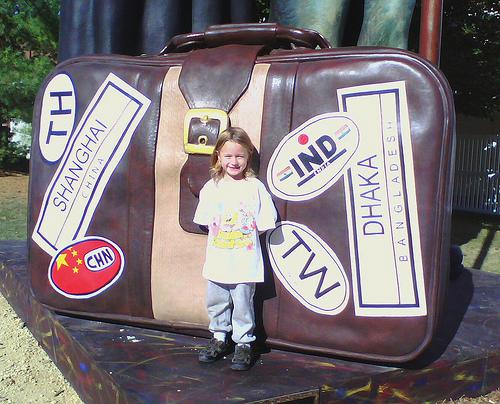Question: how many stickers are on the luggage?
Choices:
A. 6.
B. 5.
C. 2.
D. 3.
Answer with the letter. Answer: A Question: where is there a tree or bush in the photo?
Choices:
A. By the front door.
B. To the left of the luggage.
C. In the background.
D. By the fairway.
Answer with the letter. Answer: B Question: what is the girl standing in front of?
Choices:
A. Bench.
B. Store front.
C. Toys.
D. A giant piece of luggage.
Answer with the letter. Answer: D Question: what color is the luggage?
Choices:
A. Black.
B. Pink.
C. Brown and tan.
D. Red.
Answer with the letter. Answer: C 